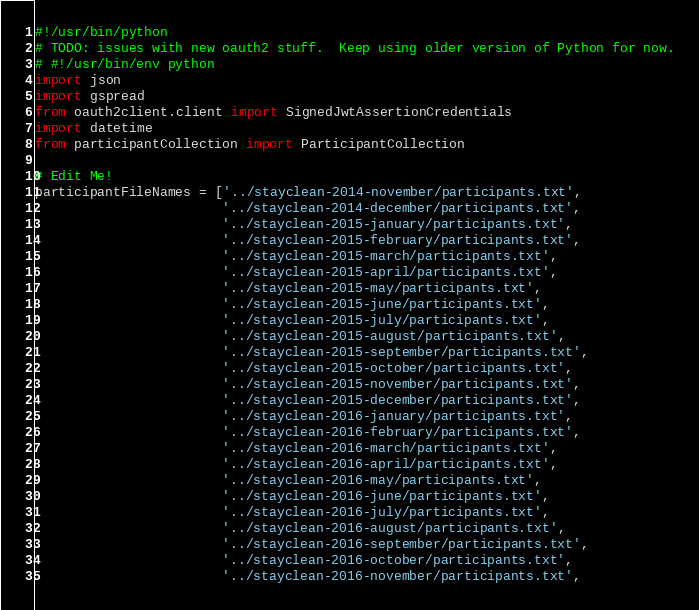<code> <loc_0><loc_0><loc_500><loc_500><_Python_>#!/usr/bin/python
# TODO: issues with new oauth2 stuff.  Keep using older version of Python for now.
# #!/usr/bin/env python
import json
import gspread
from oauth2client.client import SignedJwtAssertionCredentials
import datetime
from participantCollection import ParticipantCollection

# Edit Me!
participantFileNames = ['../stayclean-2014-november/participants.txt',
                        '../stayclean-2014-december/participants.txt',
                        '../stayclean-2015-january/participants.txt',
                        '../stayclean-2015-february/participants.txt',
                        '../stayclean-2015-march/participants.txt',
                        '../stayclean-2015-april/participants.txt',
                        '../stayclean-2015-may/participants.txt',
                        '../stayclean-2015-june/participants.txt',
                        '../stayclean-2015-july/participants.txt',
                        '../stayclean-2015-august/participants.txt',
                        '../stayclean-2015-september/participants.txt',
                        '../stayclean-2015-october/participants.txt',
                        '../stayclean-2015-november/participants.txt',
                        '../stayclean-2015-december/participants.txt',
                        '../stayclean-2016-january/participants.txt',
                        '../stayclean-2016-february/participants.txt',
                        '../stayclean-2016-march/participants.txt',
                        '../stayclean-2016-april/participants.txt',
                        '../stayclean-2016-may/participants.txt',
                        '../stayclean-2016-june/participants.txt',
                        '../stayclean-2016-july/participants.txt',
                        '../stayclean-2016-august/participants.txt',
                        '../stayclean-2016-september/participants.txt',
                        '../stayclean-2016-october/participants.txt',
                        '../stayclean-2016-november/participants.txt',</code> 